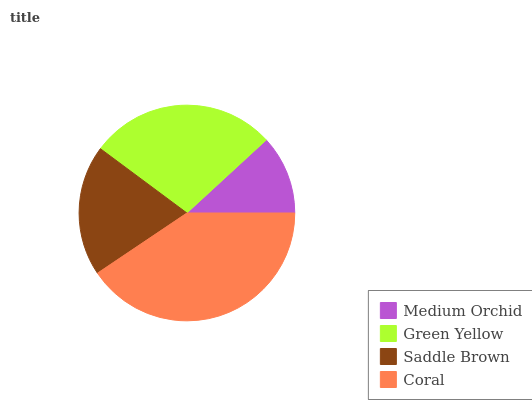Is Medium Orchid the minimum?
Answer yes or no. Yes. Is Coral the maximum?
Answer yes or no. Yes. Is Green Yellow the minimum?
Answer yes or no. No. Is Green Yellow the maximum?
Answer yes or no. No. Is Green Yellow greater than Medium Orchid?
Answer yes or no. Yes. Is Medium Orchid less than Green Yellow?
Answer yes or no. Yes. Is Medium Orchid greater than Green Yellow?
Answer yes or no. No. Is Green Yellow less than Medium Orchid?
Answer yes or no. No. Is Green Yellow the high median?
Answer yes or no. Yes. Is Saddle Brown the low median?
Answer yes or no. Yes. Is Saddle Brown the high median?
Answer yes or no. No. Is Green Yellow the low median?
Answer yes or no. No. 